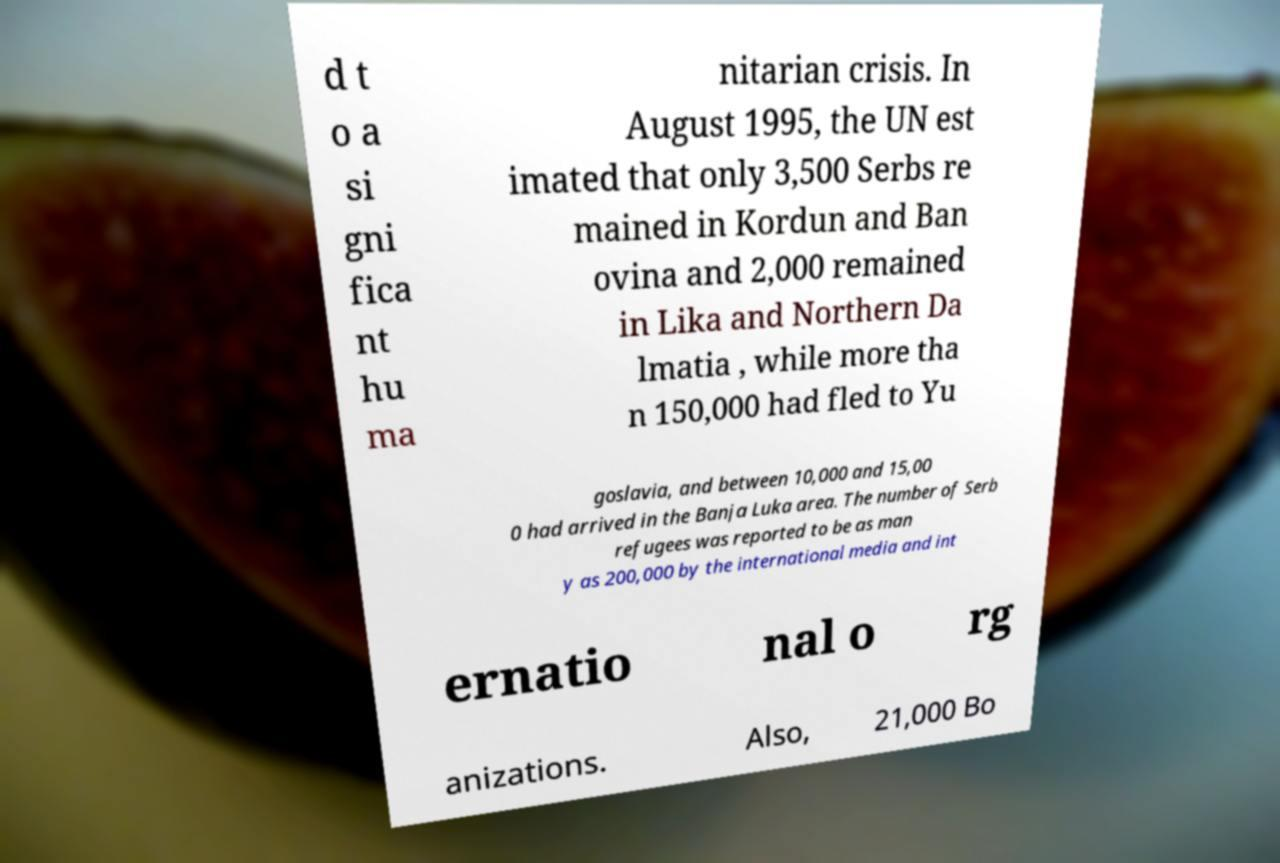Could you assist in decoding the text presented in this image and type it out clearly? d t o a si gni fica nt hu ma nitarian crisis. In August 1995, the UN est imated that only 3,500 Serbs re mained in Kordun and Ban ovina and 2,000 remained in Lika and Northern Da lmatia , while more tha n 150,000 had fled to Yu goslavia, and between 10,000 and 15,00 0 had arrived in the Banja Luka area. The number of Serb refugees was reported to be as man y as 200,000 by the international media and int ernatio nal o rg anizations. Also, 21,000 Bo 